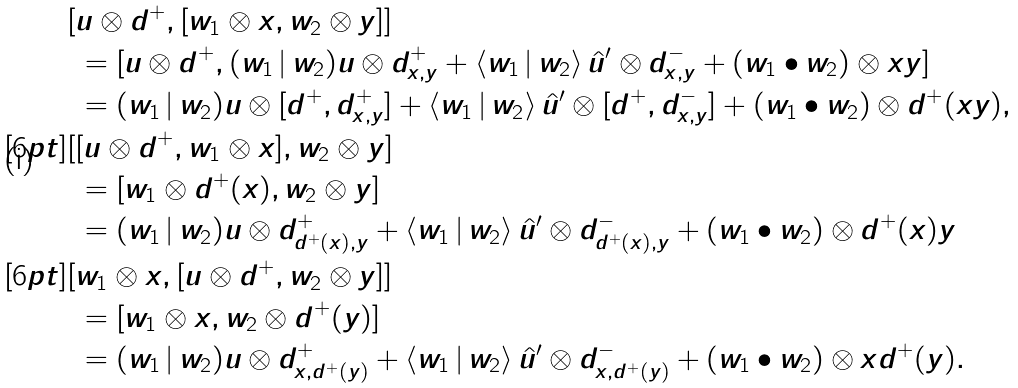Convert formula to latex. <formula><loc_0><loc_0><loc_500><loc_500>& [ u \otimes d ^ { + } , [ w _ { 1 } \otimes x , w _ { 2 } \otimes y ] ] \\ & \ = [ u \otimes d ^ { + } , ( w _ { 1 } \, | \, w _ { 2 } ) u \otimes d _ { x , y } ^ { + } + \langle w _ { 1 } \, | \, w _ { 2 } \rangle { \, } \hat { u } ^ { \prime } \otimes d _ { x , y } ^ { - } + ( w _ { 1 } \bullet w _ { 2 } ) \otimes x y ] \\ & \ = ( w _ { 1 } \, | \, w _ { 2 } ) u \otimes [ d ^ { + } , d _ { x , y } ^ { + } ] + \langle w _ { 1 } \, | \, w _ { 2 } \rangle { \, } \hat { u } ^ { \prime } \otimes [ d ^ { + } , d _ { x , y } ^ { - } ] + ( w _ { 1 } \bullet w _ { 2 } ) \otimes d ^ { + } ( x y ) , \\ [ 6 p t ] & [ [ u \otimes d ^ { + } , w _ { 1 } \otimes x ] , w _ { 2 } \otimes y ] \\ & \ = [ w _ { 1 } \otimes d ^ { + } ( x ) , w _ { 2 } \otimes y ] \\ & \ = ( w _ { 1 } \, | \, w _ { 2 } ) u \otimes d _ { d ^ { + } ( x ) , y } ^ { + } + \langle w _ { 1 } \, | \, w _ { 2 } \rangle { \, } \hat { u } ^ { \prime } \otimes d _ { d ^ { + } ( x ) , y } ^ { - } + ( w _ { 1 } \bullet w _ { 2 } ) \otimes d ^ { + } ( x ) y \\ [ 6 p t ] & [ w _ { 1 } \otimes x , [ u \otimes d ^ { + } , w _ { 2 } \otimes y ] ] \\ & \ = [ w _ { 1 } \otimes x , w _ { 2 } \otimes d ^ { + } ( y ) ] \\ & \ = ( w _ { 1 } \, | \, w _ { 2 } ) u \otimes d _ { x , d ^ { + } ( y ) } ^ { + } + \langle w _ { 1 } \, | \, w _ { 2 } \rangle { \, } \hat { u } ^ { \prime } \otimes d _ { x , d ^ { + } ( y ) } ^ { - } + ( w _ { 1 } \bullet w _ { 2 } ) \otimes x d ^ { + } ( y ) .</formula> 